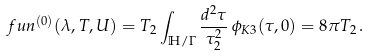Convert formula to latex. <formula><loc_0><loc_0><loc_500><loc_500>\ f u n ^ { ( 0 ) } ( \lambda , T , U ) = T _ { 2 } \int _ { \mathbb { H } / \Gamma } \frac { d ^ { 2 } \tau } { \tau _ { 2 } ^ { 2 } } \, \phi _ { K 3 } ( \tau , 0 ) = 8 \pi T _ { 2 } \, .</formula> 